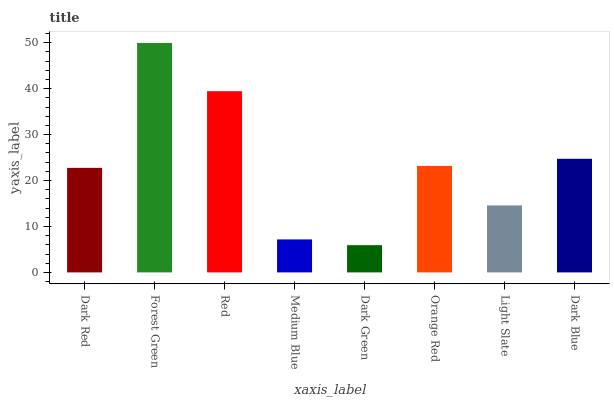Is Dark Green the minimum?
Answer yes or no. Yes. Is Forest Green the maximum?
Answer yes or no. Yes. Is Red the minimum?
Answer yes or no. No. Is Red the maximum?
Answer yes or no. No. Is Forest Green greater than Red?
Answer yes or no. Yes. Is Red less than Forest Green?
Answer yes or no. Yes. Is Red greater than Forest Green?
Answer yes or no. No. Is Forest Green less than Red?
Answer yes or no. No. Is Orange Red the high median?
Answer yes or no. Yes. Is Dark Red the low median?
Answer yes or no. Yes. Is Forest Green the high median?
Answer yes or no. No. Is Dark Green the low median?
Answer yes or no. No. 